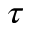Convert formula to latex. <formula><loc_0><loc_0><loc_500><loc_500>\tau</formula> 